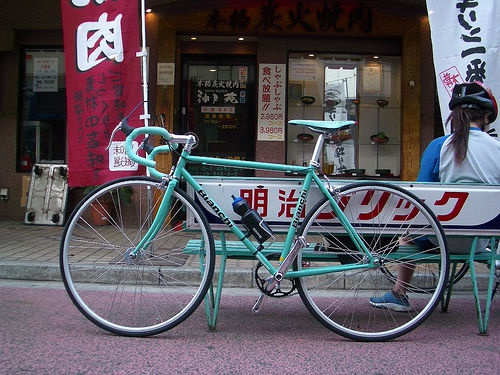Describe the objects in this image and their specific colors. I can see bicycle in black, gray, and darkgray tones, bench in black, darkgray, and gray tones, bench in black, darkgray, gray, and teal tones, people in black, gray, darkgray, and lightblue tones, and bottle in black, gray, and navy tones in this image. 